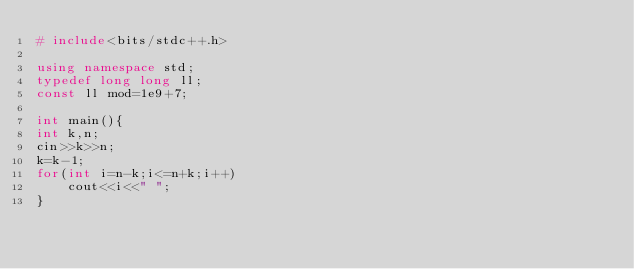Convert code to text. <code><loc_0><loc_0><loc_500><loc_500><_C++_># include<bits/stdc++.h>

using namespace std;
typedef long long ll;
const ll mod=1e9+7;

int main(){
int k,n;
cin>>k>>n;
k=k-1;
for(int i=n-k;i<=n+k;i++)
    cout<<i<<" ";
}
</code> 